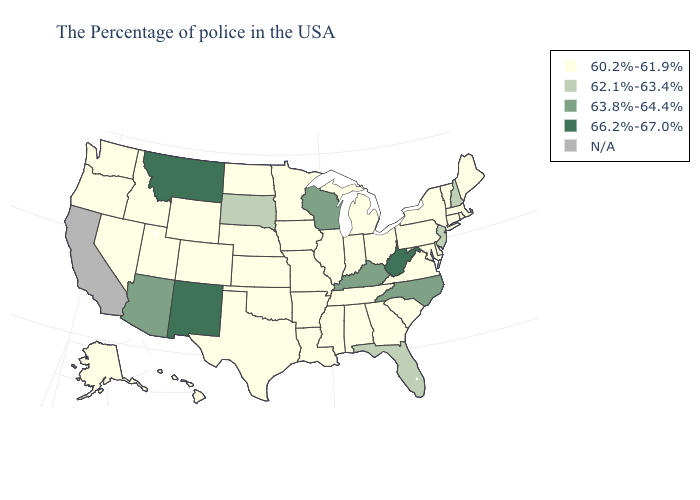How many symbols are there in the legend?
Concise answer only. 5. Among the states that border Tennessee , does Virginia have the lowest value?
Concise answer only. Yes. What is the highest value in the Northeast ?
Concise answer only. 62.1%-63.4%. Name the states that have a value in the range 66.2%-67.0%?
Quick response, please. West Virginia, New Mexico, Montana. Name the states that have a value in the range 60.2%-61.9%?
Answer briefly. Maine, Massachusetts, Rhode Island, Vermont, Connecticut, New York, Delaware, Maryland, Pennsylvania, Virginia, South Carolina, Ohio, Georgia, Michigan, Indiana, Alabama, Tennessee, Illinois, Mississippi, Louisiana, Missouri, Arkansas, Minnesota, Iowa, Kansas, Nebraska, Oklahoma, Texas, North Dakota, Wyoming, Colorado, Utah, Idaho, Nevada, Washington, Oregon, Alaska, Hawaii. Which states have the highest value in the USA?
Concise answer only. West Virginia, New Mexico, Montana. What is the lowest value in states that border Alabama?
Keep it brief. 60.2%-61.9%. What is the value of Alaska?
Concise answer only. 60.2%-61.9%. Does the map have missing data?
Be succinct. Yes. What is the highest value in states that border Colorado?
Be succinct. 66.2%-67.0%. Name the states that have a value in the range 62.1%-63.4%?
Keep it brief. New Hampshire, New Jersey, Florida, South Dakota. What is the highest value in the USA?
Write a very short answer. 66.2%-67.0%. Does Maryland have the lowest value in the South?
Keep it brief. Yes. Among the states that border Rhode Island , which have the lowest value?
Give a very brief answer. Massachusetts, Connecticut. 